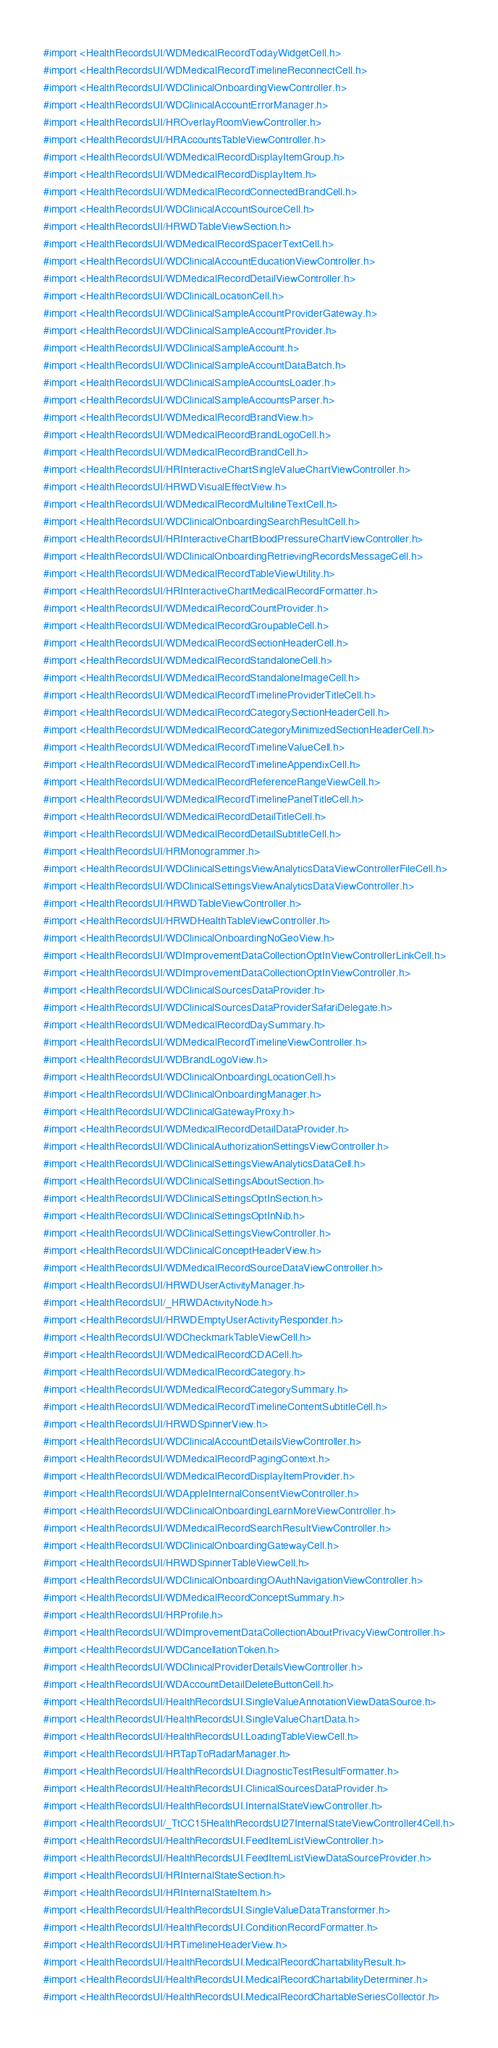Convert code to text. <code><loc_0><loc_0><loc_500><loc_500><_C_>#import <HealthRecordsUI/WDMedicalRecordTodayWidgetCell.h>
#import <HealthRecordsUI/WDMedicalRecordTimelineReconnectCell.h>
#import <HealthRecordsUI/WDClinicalOnboardingViewController.h>
#import <HealthRecordsUI/WDClinicalAccountErrorManager.h>
#import <HealthRecordsUI/HROverlayRoomViewController.h>
#import <HealthRecordsUI/HRAccountsTableViewController.h>
#import <HealthRecordsUI/WDMedicalRecordDisplayItemGroup.h>
#import <HealthRecordsUI/WDMedicalRecordDisplayItem.h>
#import <HealthRecordsUI/WDMedicalRecordConnectedBrandCell.h>
#import <HealthRecordsUI/WDClinicalAccountSourceCell.h>
#import <HealthRecordsUI/HRWDTableViewSection.h>
#import <HealthRecordsUI/WDMedicalRecordSpacerTextCell.h>
#import <HealthRecordsUI/WDClinicalAccountEducationViewController.h>
#import <HealthRecordsUI/WDMedicalRecordDetailViewController.h>
#import <HealthRecordsUI/WDClinicalLocationCell.h>
#import <HealthRecordsUI/WDClinicalSampleAccountProviderGateway.h>
#import <HealthRecordsUI/WDClinicalSampleAccountProvider.h>
#import <HealthRecordsUI/WDClinicalSampleAccount.h>
#import <HealthRecordsUI/WDClinicalSampleAccountDataBatch.h>
#import <HealthRecordsUI/WDClinicalSampleAccountsLoader.h>
#import <HealthRecordsUI/WDClinicalSampleAccountsParser.h>
#import <HealthRecordsUI/WDMedicalRecordBrandView.h>
#import <HealthRecordsUI/WDMedicalRecordBrandLogoCell.h>
#import <HealthRecordsUI/WDMedicalRecordBrandCell.h>
#import <HealthRecordsUI/HRInteractiveChartSingleValueChartViewController.h>
#import <HealthRecordsUI/HRWDVisualEffectView.h>
#import <HealthRecordsUI/WDMedicalRecordMultilineTextCell.h>
#import <HealthRecordsUI/WDClinicalOnboardingSearchResultCell.h>
#import <HealthRecordsUI/HRInteractiveChartBloodPressureChartViewController.h>
#import <HealthRecordsUI/WDClinicalOnboardingRetrievingRecordsMessageCell.h>
#import <HealthRecordsUI/WDMedicalRecordTableViewUtility.h>
#import <HealthRecordsUI/HRInteractiveChartMedicalRecordFormatter.h>
#import <HealthRecordsUI/WDMedicalRecordCountProvider.h>
#import <HealthRecordsUI/WDMedicalRecordGroupableCell.h>
#import <HealthRecordsUI/WDMedicalRecordSectionHeaderCell.h>
#import <HealthRecordsUI/WDMedicalRecordStandaloneCell.h>
#import <HealthRecordsUI/WDMedicalRecordStandaloneImageCell.h>
#import <HealthRecordsUI/WDMedicalRecordTimelineProviderTitleCell.h>
#import <HealthRecordsUI/WDMedicalRecordCategorySectionHeaderCell.h>
#import <HealthRecordsUI/WDMedicalRecordCategoryMinimizedSectionHeaderCell.h>
#import <HealthRecordsUI/WDMedicalRecordTimelineValueCell.h>
#import <HealthRecordsUI/WDMedicalRecordTimelineAppendixCell.h>
#import <HealthRecordsUI/WDMedicalRecordReferenceRangeViewCell.h>
#import <HealthRecordsUI/WDMedicalRecordTimelinePanelTitleCell.h>
#import <HealthRecordsUI/WDMedicalRecordDetailTitleCell.h>
#import <HealthRecordsUI/WDMedicalRecordDetailSubtitleCell.h>
#import <HealthRecordsUI/HRMonogrammer.h>
#import <HealthRecordsUI/WDClinicalSettingsViewAnalyticsDataViewControllerFileCell.h>
#import <HealthRecordsUI/WDClinicalSettingsViewAnalyticsDataViewController.h>
#import <HealthRecordsUI/HRWDTableViewController.h>
#import <HealthRecordsUI/HRWDHealthTableViewController.h>
#import <HealthRecordsUI/WDClinicalOnboardingNoGeoView.h>
#import <HealthRecordsUI/WDImprovementDataCollectionOptInViewControllerLinkCell.h>
#import <HealthRecordsUI/WDImprovementDataCollectionOptInViewController.h>
#import <HealthRecordsUI/WDClinicalSourcesDataProvider.h>
#import <HealthRecordsUI/WDClinicalSourcesDataProviderSafariDelegate.h>
#import <HealthRecordsUI/WDMedicalRecordDaySummary.h>
#import <HealthRecordsUI/WDMedicalRecordTimelineViewController.h>
#import <HealthRecordsUI/WDBrandLogoView.h>
#import <HealthRecordsUI/WDClinicalOnboardingLocationCell.h>
#import <HealthRecordsUI/WDClinicalOnboardingManager.h>
#import <HealthRecordsUI/WDClinicalGatewayProxy.h>
#import <HealthRecordsUI/WDMedicalRecordDetailDataProvider.h>
#import <HealthRecordsUI/WDClinicalAuthorizationSettingsViewController.h>
#import <HealthRecordsUI/WDClinicalSettingsViewAnalyticsDataCell.h>
#import <HealthRecordsUI/WDClinicalSettingsAboutSection.h>
#import <HealthRecordsUI/WDClinicalSettingsOptInSection.h>
#import <HealthRecordsUI/WDClinicalSettingsOptInNib.h>
#import <HealthRecordsUI/WDClinicalSettingsViewController.h>
#import <HealthRecordsUI/WDClinicalConceptHeaderView.h>
#import <HealthRecordsUI/WDMedicalRecordSourceDataViewController.h>
#import <HealthRecordsUI/HRWDUserActivityManager.h>
#import <HealthRecordsUI/_HRWDActivityNode.h>
#import <HealthRecordsUI/HRWDEmptyUserActivityResponder.h>
#import <HealthRecordsUI/WDCheckmarkTableViewCell.h>
#import <HealthRecordsUI/WDMedicalRecordCDACell.h>
#import <HealthRecordsUI/WDMedicalRecordCategory.h>
#import <HealthRecordsUI/WDMedicalRecordCategorySummary.h>
#import <HealthRecordsUI/WDMedicalRecordTimelineContentSubtitleCell.h>
#import <HealthRecordsUI/HRWDSpinnerView.h>
#import <HealthRecordsUI/WDClinicalAccountDetailsViewController.h>
#import <HealthRecordsUI/WDMedicalRecordPagingContext.h>
#import <HealthRecordsUI/WDMedicalRecordDisplayItemProvider.h>
#import <HealthRecordsUI/WDAppleInternalConsentViewController.h>
#import <HealthRecordsUI/WDClinicalOnboardingLearnMoreViewController.h>
#import <HealthRecordsUI/WDMedicalRecordSearchResultViewController.h>
#import <HealthRecordsUI/WDClinicalOnboardingGatewayCell.h>
#import <HealthRecordsUI/HRWDSpinnerTableViewCell.h>
#import <HealthRecordsUI/WDClinicalOnboardingOAuthNavigationViewController.h>
#import <HealthRecordsUI/WDMedicalRecordConceptSummary.h>
#import <HealthRecordsUI/HRProfile.h>
#import <HealthRecordsUI/WDImprovementDataCollectionAboutPrivacyViewController.h>
#import <HealthRecordsUI/WDCancellationToken.h>
#import <HealthRecordsUI/WDClinicalProviderDetailsViewController.h>
#import <HealthRecordsUI/WDAccountDetailDeleteButtonCell.h>
#import <HealthRecordsUI/HealthRecordsUI.SingleValueAnnotationViewDataSource.h>
#import <HealthRecordsUI/HealthRecordsUI.SingleValueChartData.h>
#import <HealthRecordsUI/HealthRecordsUI.LoadingTableViewCell.h>
#import <HealthRecordsUI/HRTapToRadarManager.h>
#import <HealthRecordsUI/HealthRecordsUI.DiagnosticTestResultFormatter.h>
#import <HealthRecordsUI/HealthRecordsUI.ClinicalSourcesDataProvider.h>
#import <HealthRecordsUI/HealthRecordsUI.InternalStateViewController.h>
#import <HealthRecordsUI/_TtCC15HealthRecordsUI27InternalStateViewController4Cell.h>
#import <HealthRecordsUI/HealthRecordsUI.FeedItemListViewController.h>
#import <HealthRecordsUI/HealthRecordsUI.FeedItemListViewDataSourceProvider.h>
#import <HealthRecordsUI/HRInternalStateSection.h>
#import <HealthRecordsUI/HRInternalStateItem.h>
#import <HealthRecordsUI/HealthRecordsUI.SingleValueDataTransformer.h>
#import <HealthRecordsUI/HealthRecordsUI.ConditionRecordFormatter.h>
#import <HealthRecordsUI/HRTimelineHeaderView.h>
#import <HealthRecordsUI/HealthRecordsUI.MedicalRecordChartabilityResult.h>
#import <HealthRecordsUI/HealthRecordsUI.MedicalRecordChartabilityDeterminer.h>
#import <HealthRecordsUI/HealthRecordsUI.MedicalRecordChartableSeriesCollector.h></code> 